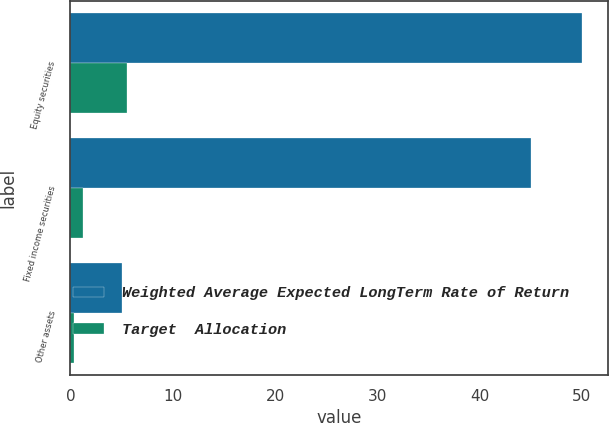<chart> <loc_0><loc_0><loc_500><loc_500><stacked_bar_chart><ecel><fcel>Equity securities<fcel>Fixed income securities<fcel>Other assets<nl><fcel>Weighted Average Expected LongTerm Rate of Return<fcel>50<fcel>45<fcel>5<nl><fcel>Target  Allocation<fcel>5.5<fcel>1.2<fcel>0.3<nl></chart> 